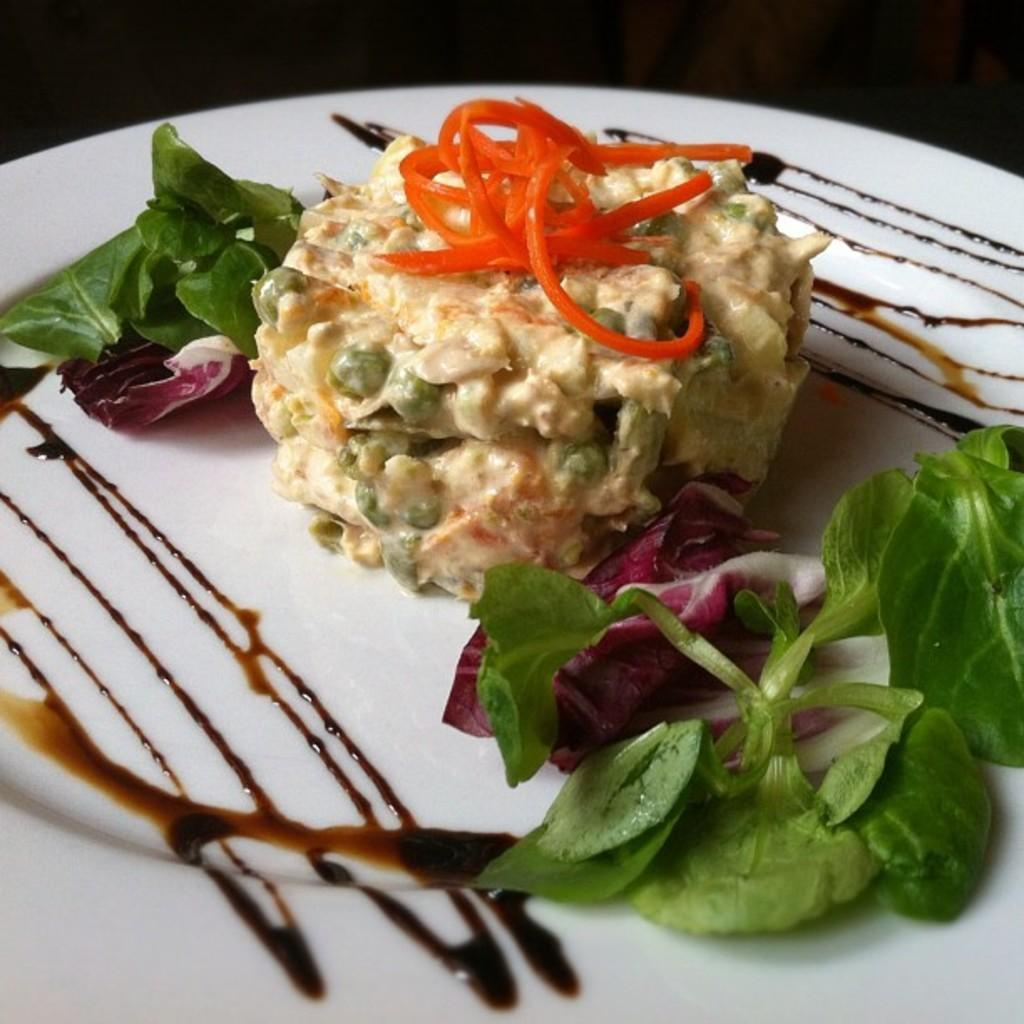What is on the plate in the image? There is a food item on a plate in the image. What color is the plate? The plate is white. What can be seen in the background of the image? The background of the image is dark. What reason does the brick have for being in the image? There is no brick present in the image, so it cannot have a reason for being there. 